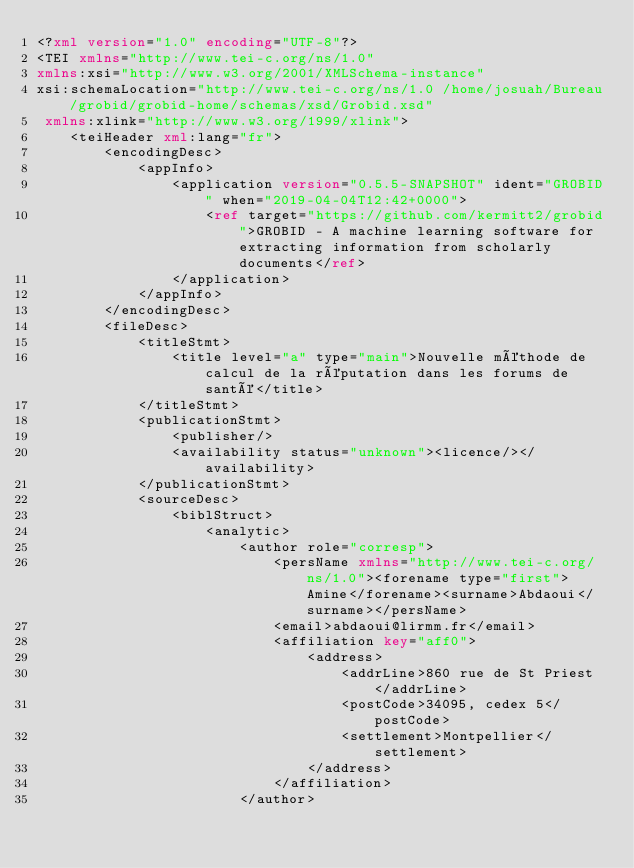Convert code to text. <code><loc_0><loc_0><loc_500><loc_500><_XML_><?xml version="1.0" encoding="UTF-8"?>
<TEI xmlns="http://www.tei-c.org/ns/1.0" 
xmlns:xsi="http://www.w3.org/2001/XMLSchema-instance" 
xsi:schemaLocation="http://www.tei-c.org/ns/1.0 /home/josuah/Bureau/grobid/grobid-home/schemas/xsd/Grobid.xsd"
 xmlns:xlink="http://www.w3.org/1999/xlink">
	<teiHeader xml:lang="fr">
		<encodingDesc>
			<appInfo>
				<application version="0.5.5-SNAPSHOT" ident="GROBID" when="2019-04-04T12:42+0000">
					<ref target="https://github.com/kermitt2/grobid">GROBID - A machine learning software for extracting information from scholarly documents</ref>
				</application>
			</appInfo>
		</encodingDesc>
		<fileDesc>
			<titleStmt>
				<title level="a" type="main">Nouvelle méthode de calcul de la réputation dans les forums de santé</title>
			</titleStmt>
			<publicationStmt>
				<publisher/>
				<availability status="unknown"><licence/></availability>
			</publicationStmt>
			<sourceDesc>
				<biblStruct>
					<analytic>
						<author role="corresp">
							<persName xmlns="http://www.tei-c.org/ns/1.0"><forename type="first">Amine</forename><surname>Abdaoui</surname></persName>
							<email>abdaoui@lirmm.fr</email>
							<affiliation key="aff0">
								<address>
									<addrLine>860 rue de St Priest</addrLine>
									<postCode>34095, cedex 5</postCode>
									<settlement>Montpellier</settlement>
								</address>
							</affiliation>
						</author></code> 